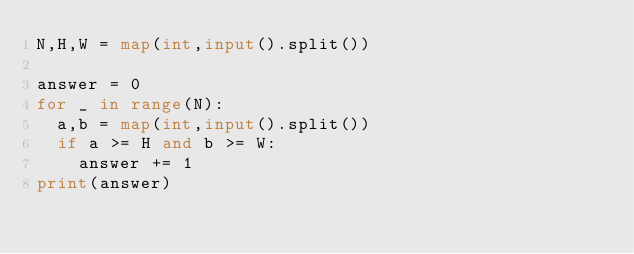Convert code to text. <code><loc_0><loc_0><loc_500><loc_500><_Python_>N,H,W = map(int,input().split())

answer = 0
for _ in range(N):
  a,b = map(int,input().split())
  if a >= H and b >= W:
    answer += 1
print(answer)</code> 